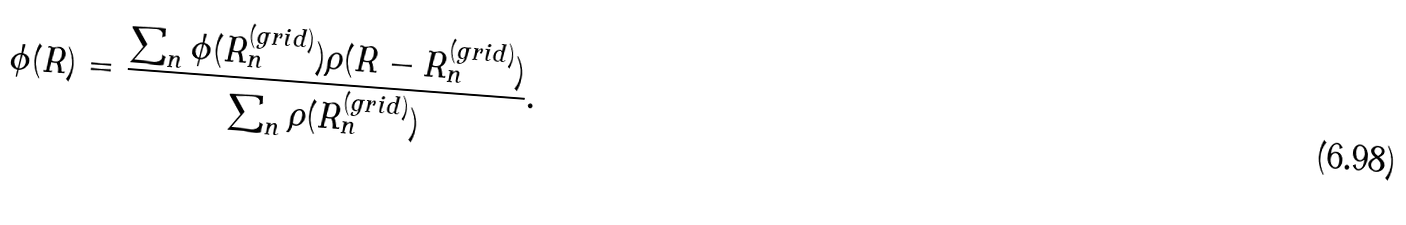<formula> <loc_0><loc_0><loc_500><loc_500>\phi ( R ) = \frac { \sum _ { n } \phi ( R ^ { ( g r i d ) } _ { n } ) \rho ( R - R ^ { ( g r i d ) } _ { n } ) } { \sum _ { n } \rho ( R ^ { ( g r i d ) } _ { n } ) } .</formula> 